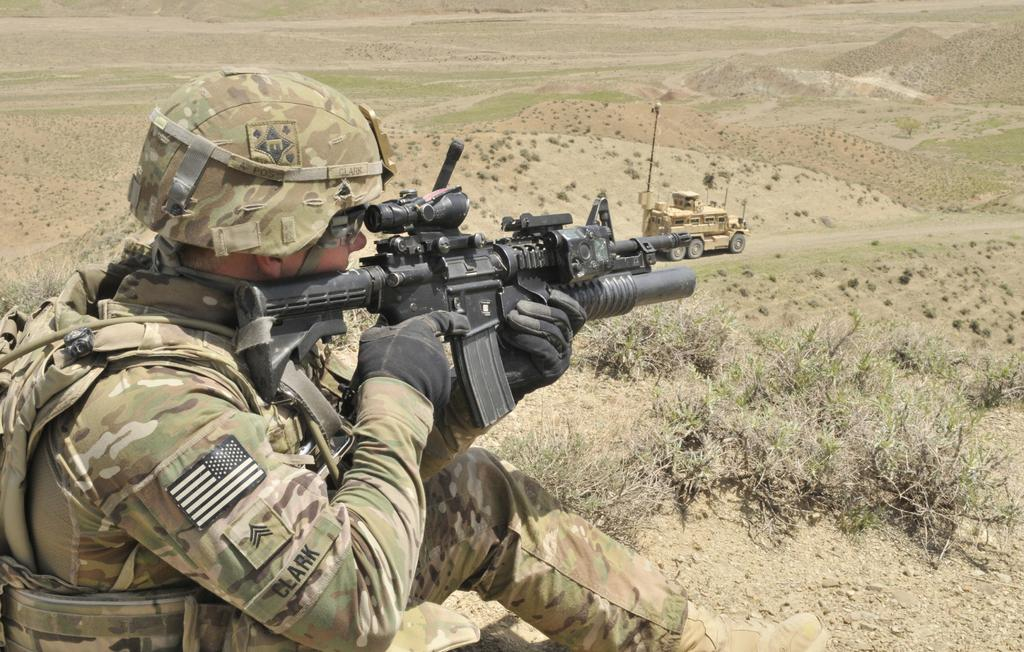What is the main subject of the image? There is a man in the image. What is the man holding in the image? The man is holding a gun. What type of clothing is the man wearing? The man is wearing military dress. What else can be seen in the image besides the man? There is a vehicle and grass in the image. What type of decision can be seen being made by the mitten in the image? There is no mitten present in the image, so no decision can be made by a mitten. 